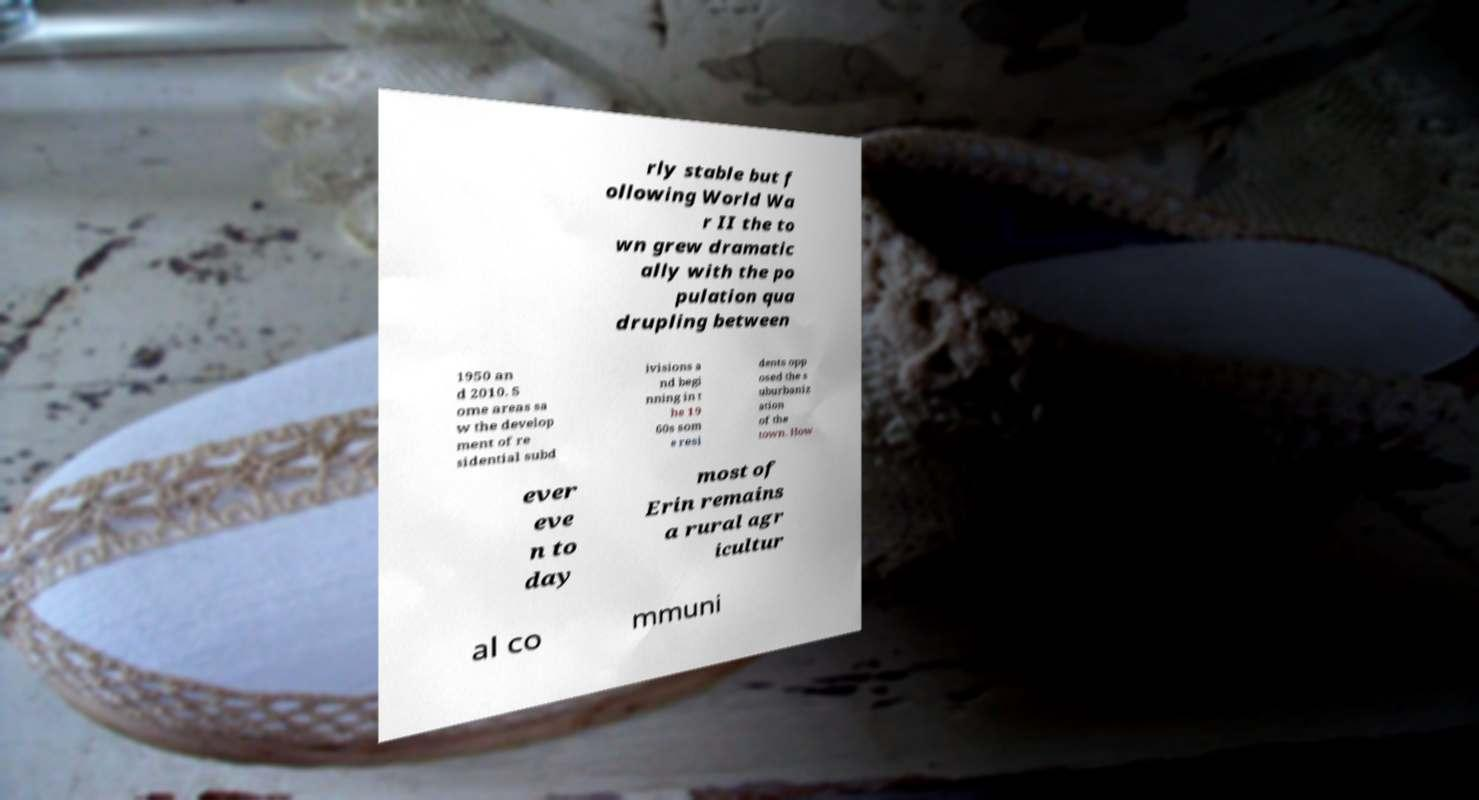There's text embedded in this image that I need extracted. Can you transcribe it verbatim? rly stable but f ollowing World Wa r II the to wn grew dramatic ally with the po pulation qua drupling between 1950 an d 2010. S ome areas sa w the develop ment of re sidential subd ivisions a nd begi nning in t he 19 60s som e resi dents opp osed the s uburbaniz ation of the town. How ever eve n to day most of Erin remains a rural agr icultur al co mmuni 